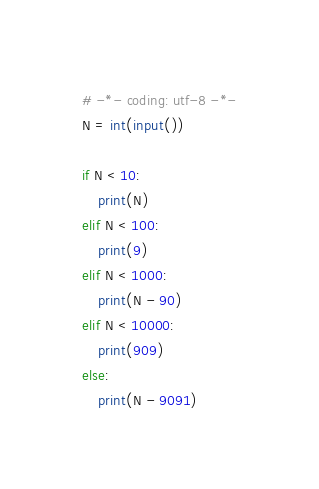Convert code to text. <code><loc_0><loc_0><loc_500><loc_500><_Python_># -*- coding: utf-8 -*-
N = int(input())

if N < 10:
    print(N)
elif N < 100:
    print(9)
elif N < 1000:
    print(N - 90)
elif N < 10000:
    print(909)
else:
    print(N - 9091)</code> 